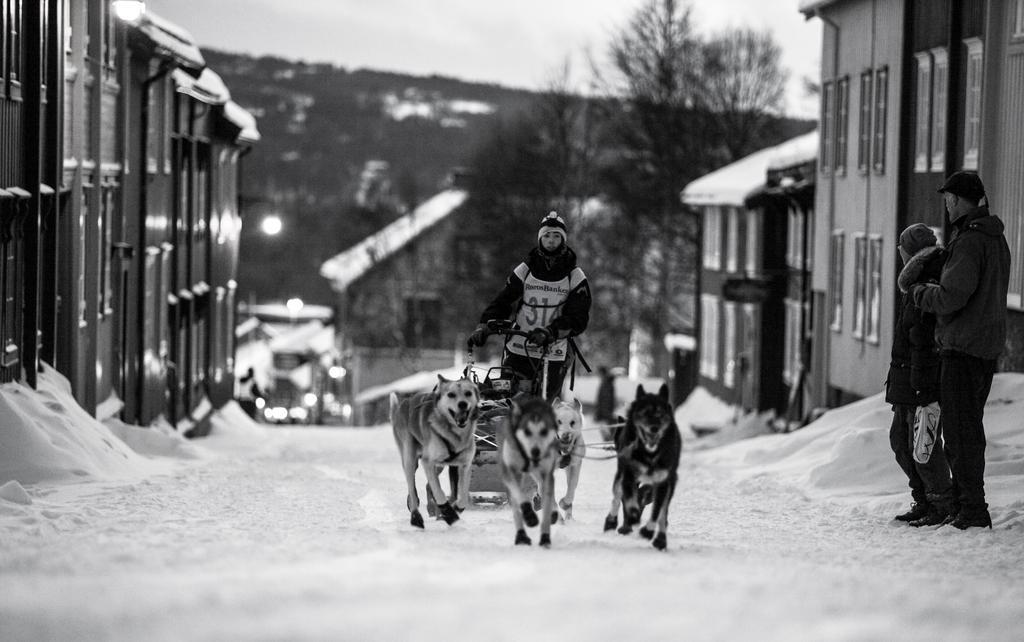Please provide a concise description of this image. In this image we can see this person is carrying four dogs in front of him. In the background we can see buildings and trees. 